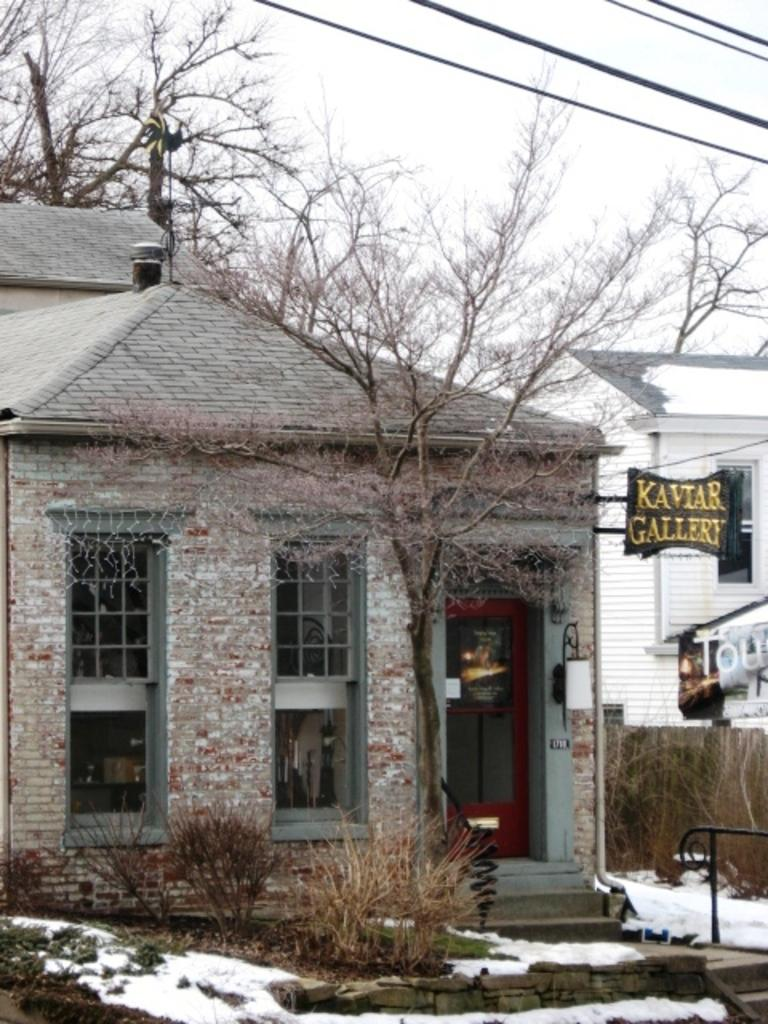What type of structures can be seen in the image? There are houses with windows in the image. What natural elements are present in the image? Trees and plants are visible in the image. What weather condition is depicted in the image? Snow is present in the image. Where is the lamp located in the image? A lamp is attached to a wall in the image. How many slaves are visible in the image? There are no slaves present in the image. What type of knee injury can be seen in the image? There is no knee injury depicted in the image. 